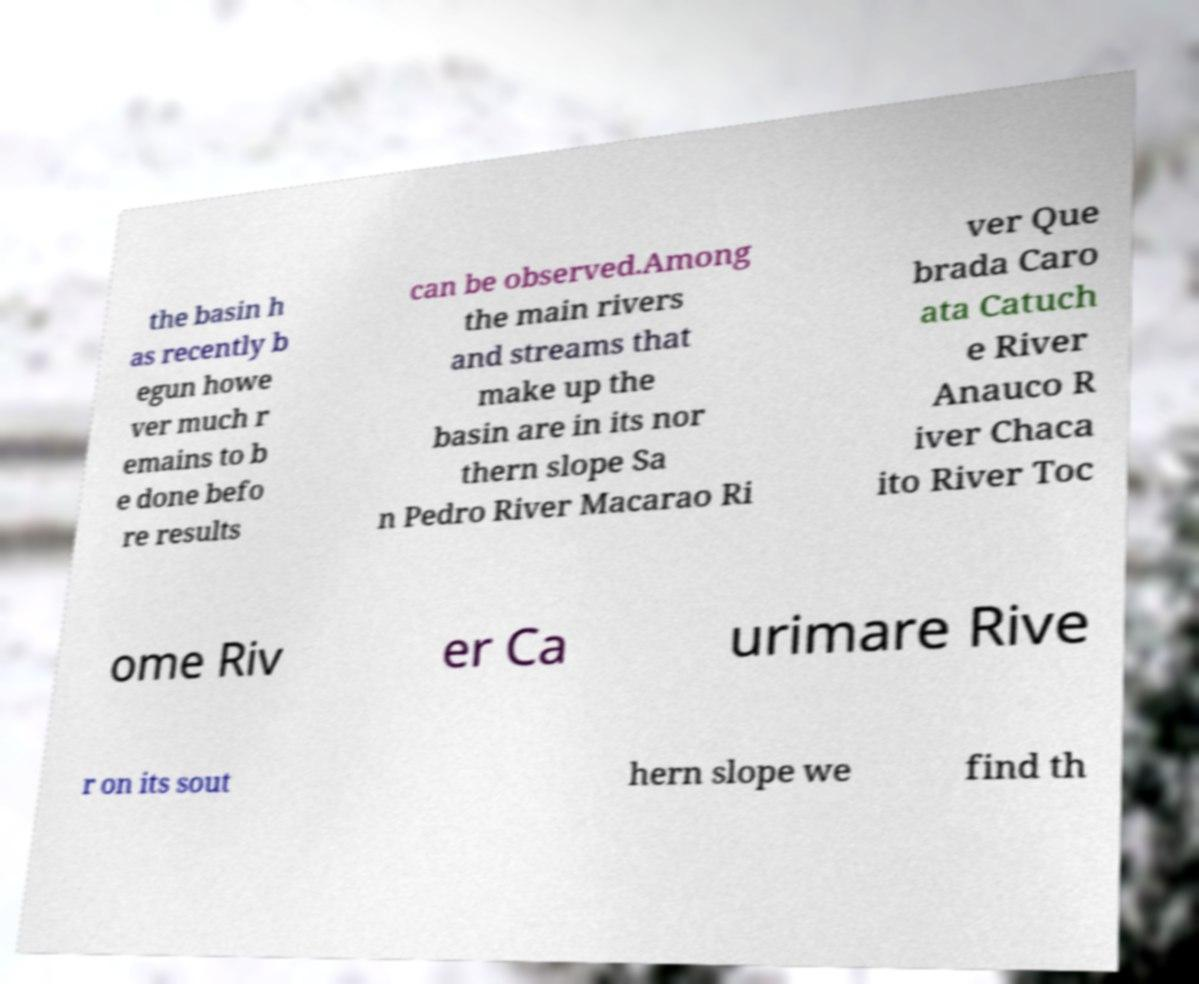Please identify and transcribe the text found in this image. the basin h as recently b egun howe ver much r emains to b e done befo re results can be observed.Among the main rivers and streams that make up the basin are in its nor thern slope Sa n Pedro River Macarao Ri ver Que brada Caro ata Catuch e River Anauco R iver Chaca ito River Toc ome Riv er Ca urimare Rive r on its sout hern slope we find th 